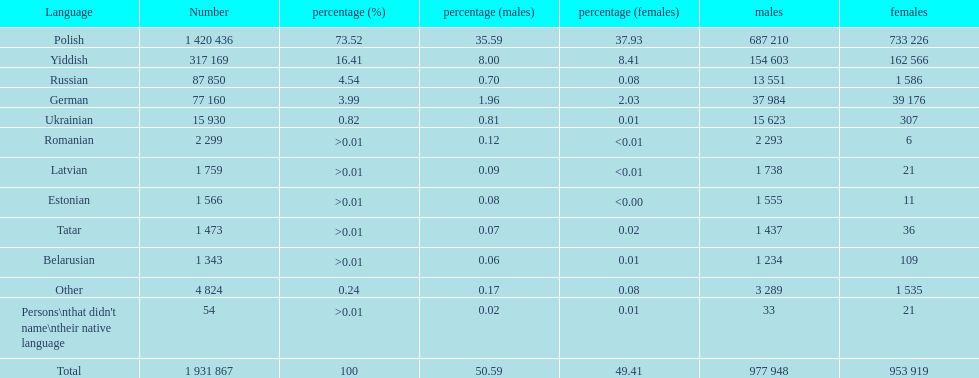What was the top language from the one's whose percentage was >0.01 Romanian. 